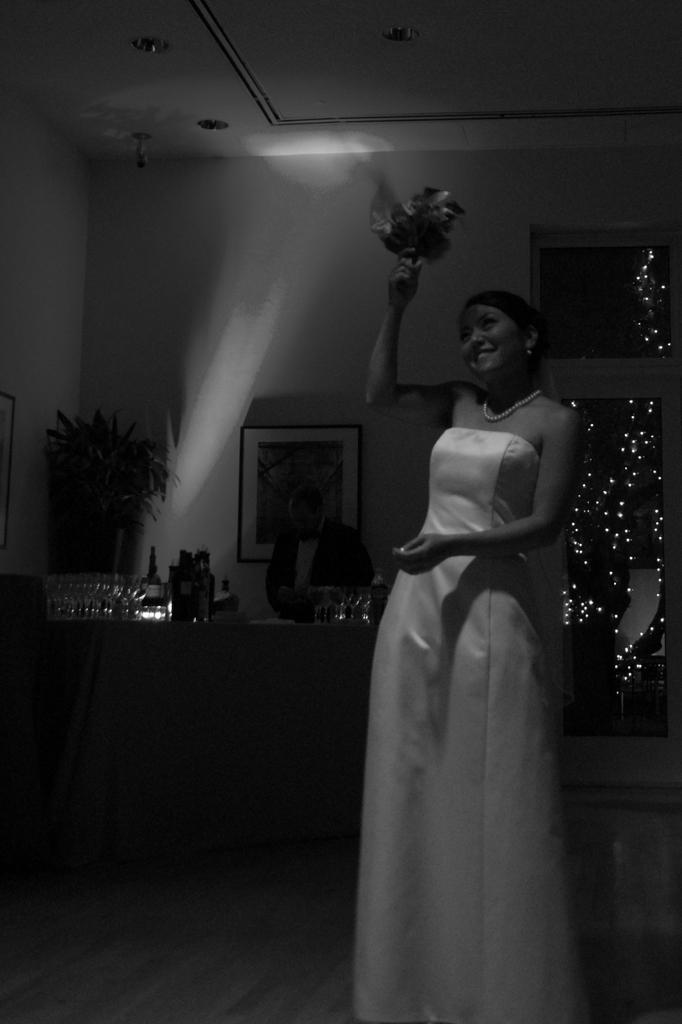What is the lady in the image doing? The lady is standing in the image and holding flowers in her hands. What can be seen on the table in the image? There are bottles on the table in the image. Are there any decorative items on the wall in the image? Yes, there are photo frames on the wall in the image. What is the rate of the sea visible in the image? There is no sea visible in the image, so it is not possible to determine the rate of the sea. 